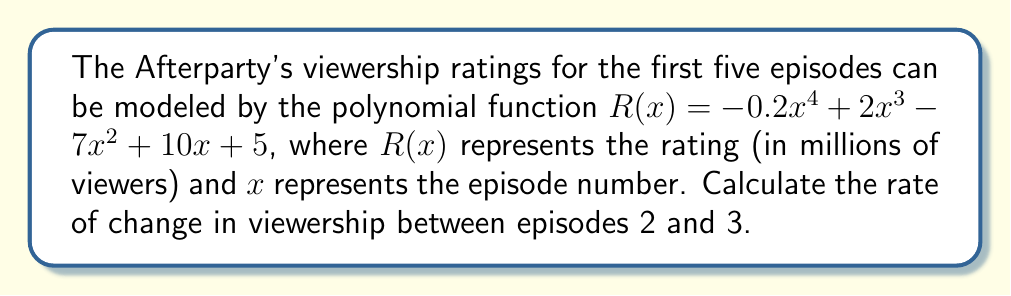Help me with this question. To find the rate of change in viewership between episodes 2 and 3, we need to calculate the average rate of change of the function $R(x)$ over the interval $[2, 3]$. This can be done using the following steps:

1. Calculate $R(2)$ and $R(3)$:

   $R(2) = -0.2(2^4) + 2(2^3) - 7(2^2) + 10(2) + 5$
         $= -3.2 + 16 - 28 + 20 + 5$
         $= 9.8$ million viewers

   $R(3) = -0.2(3^4) + 2(3^3) - 7(3^2) + 10(3) + 5$
         $= -16.2 + 54 - 63 + 30 + 5$
         $= 9.8$ million viewers

2. Calculate the average rate of change using the formula:

   $$\text{Rate of change} = \frac{R(3) - R(2)}{3 - 2}$$

3. Substitute the values:

   $$\text{Rate of change} = \frac{9.8 - 9.8}{3 - 2} = \frac{0}{1} = 0$$

The rate of change in viewership between episodes 2 and 3 is 0 million viewers per episode, indicating that the viewership remained constant between these two episodes.
Answer: 0 million viewers per episode 